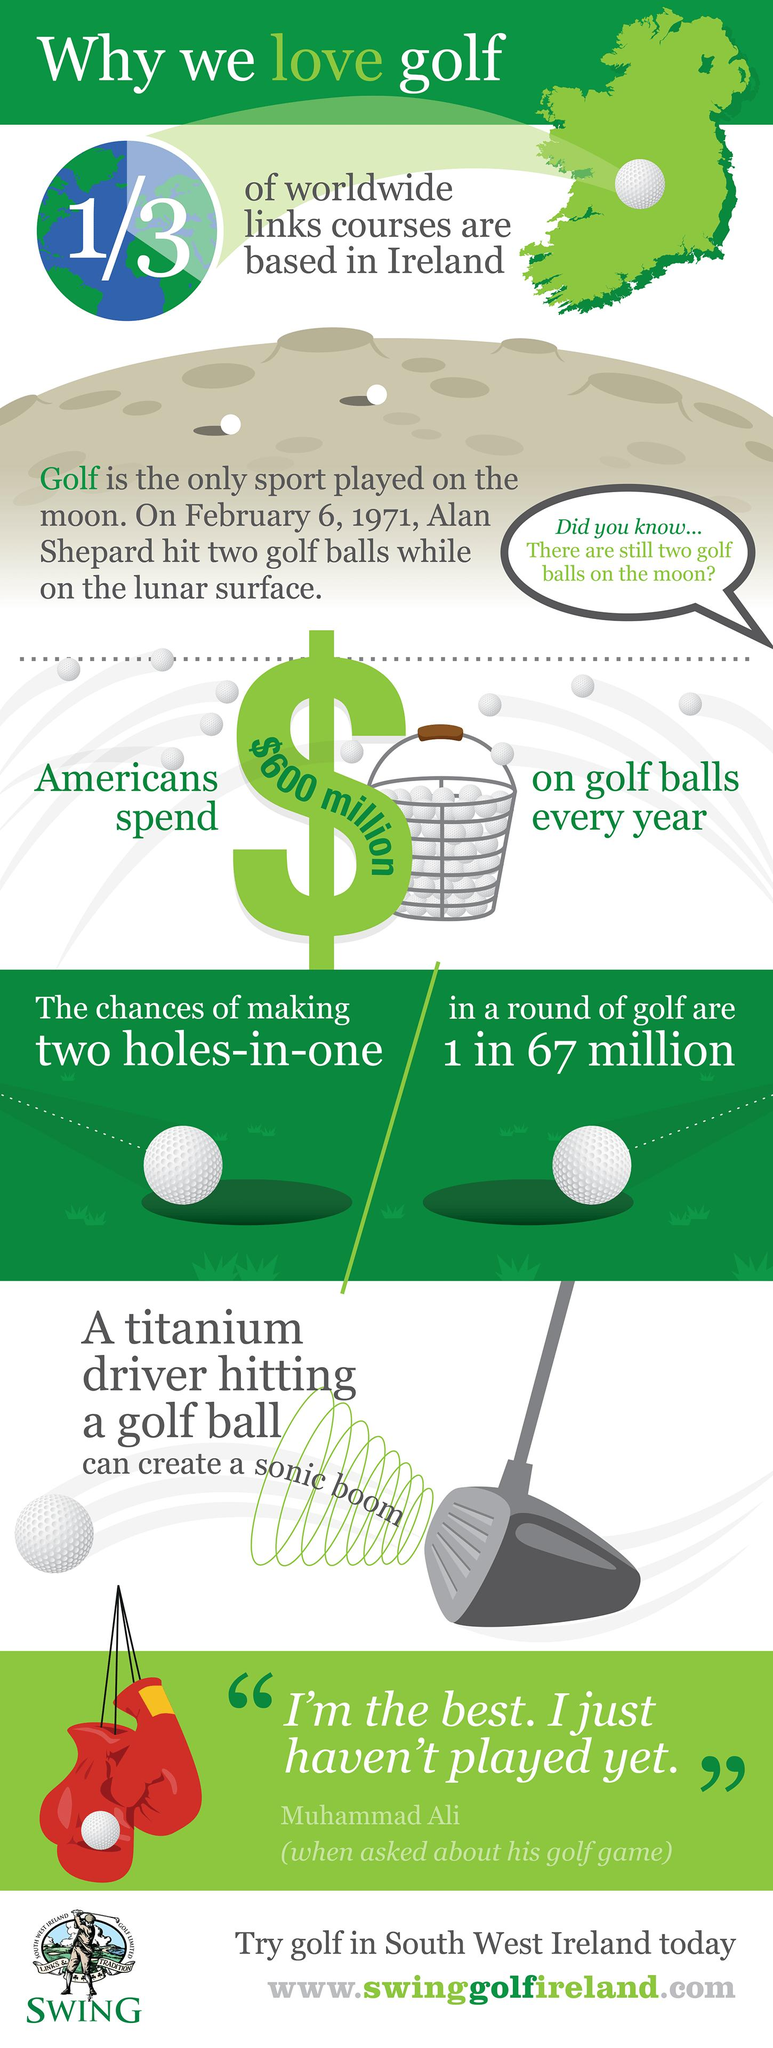Identify some key points in this picture. Muhammad Ali, the famous boxer, declared that he is the best and has not yet played golf. In the United States, Americans spend approximately $600 million on golf balls each year. It is a well-known fact that golf is the only sport that has been played on the moon. This is a proven fact that cannot be disputed. 